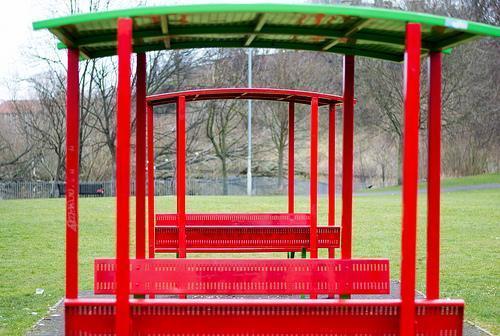How many benches are under the gazebo?
Give a very brief answer. 2. 